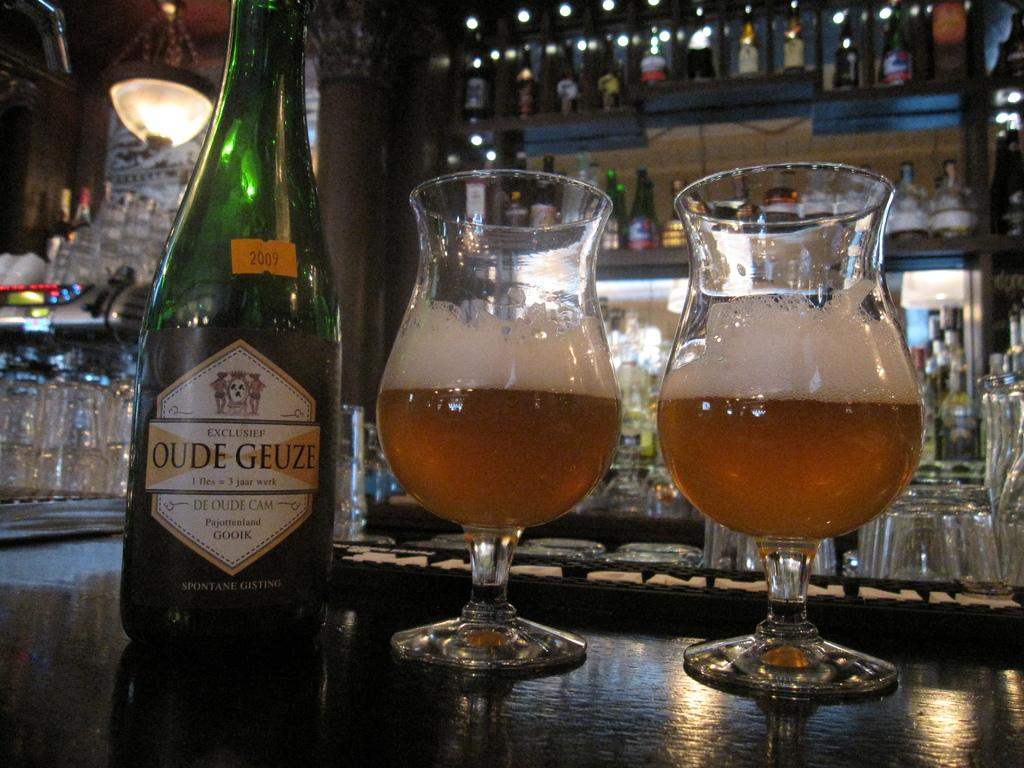<image>
Relay a brief, clear account of the picture shown. 2  glasses filled with Oude Geuze ale is on the bar in front of many glasses. 